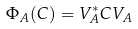Convert formula to latex. <formula><loc_0><loc_0><loc_500><loc_500>\Phi _ { A } ( C ) = V _ { A } ^ { * } C V _ { A }</formula> 